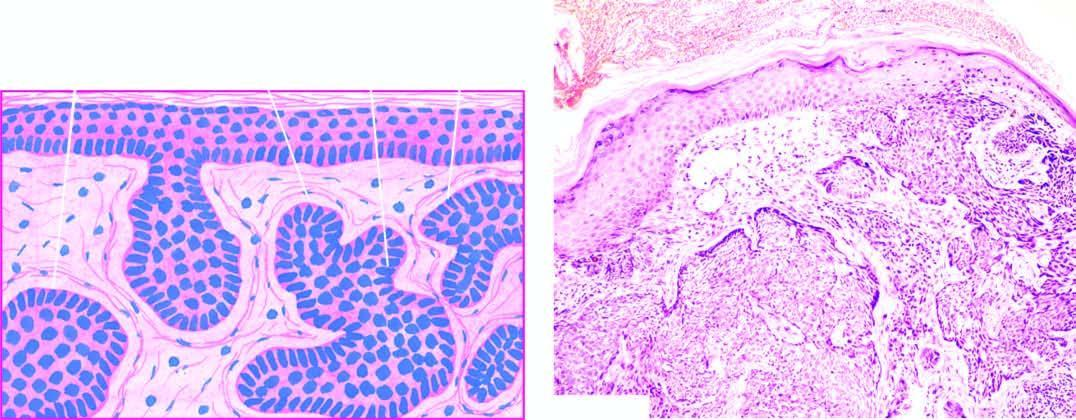s the dermis invaded by irregular masses of basaloid cells with characteristic peripheral palisaded appearance?
Answer the question using a single word or phrase. Yes 